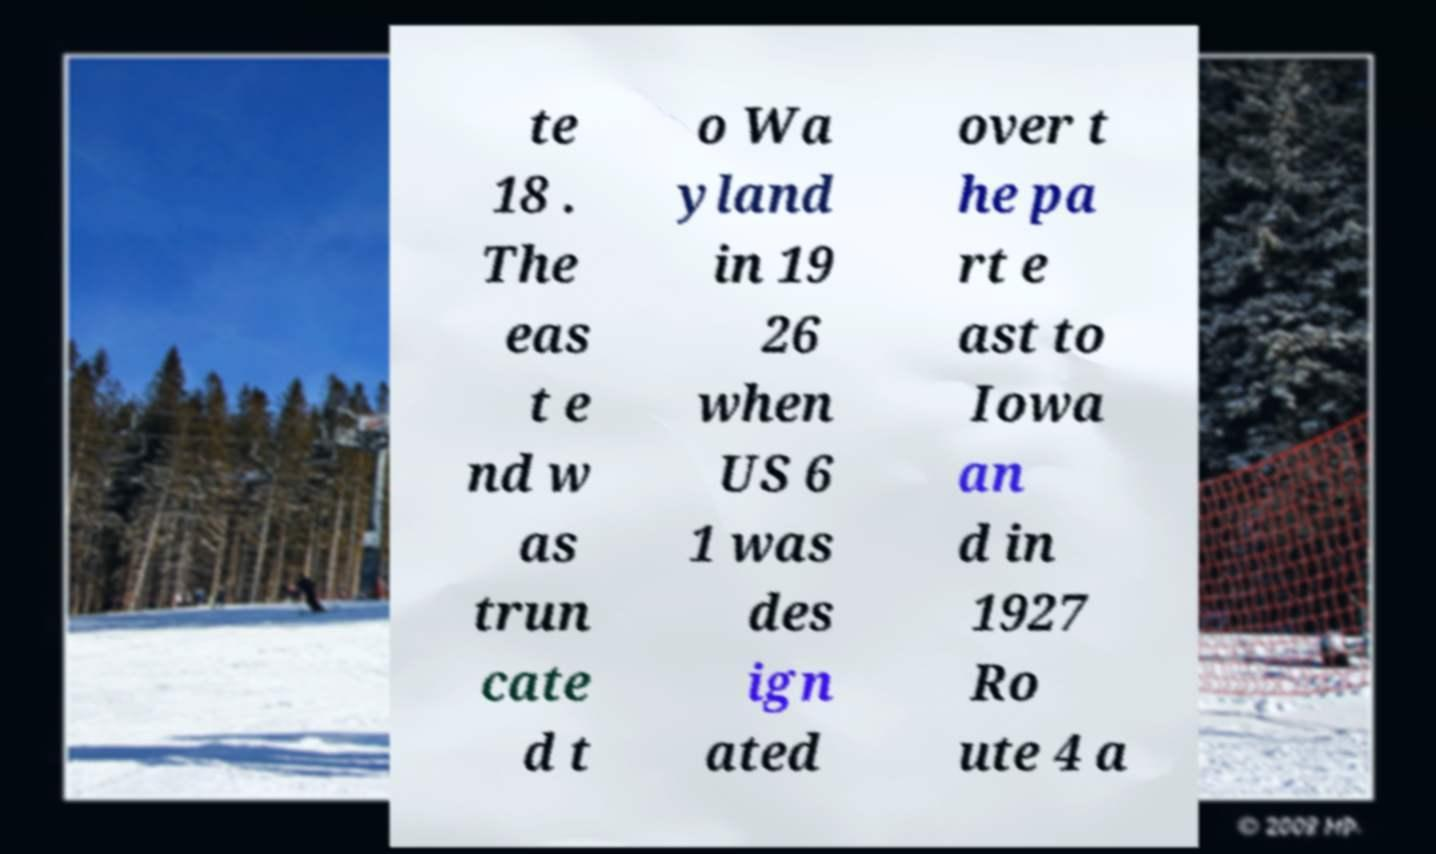There's text embedded in this image that I need extracted. Can you transcribe it verbatim? te 18 . The eas t e nd w as trun cate d t o Wa yland in 19 26 when US 6 1 was des ign ated over t he pa rt e ast to Iowa an d in 1927 Ro ute 4 a 